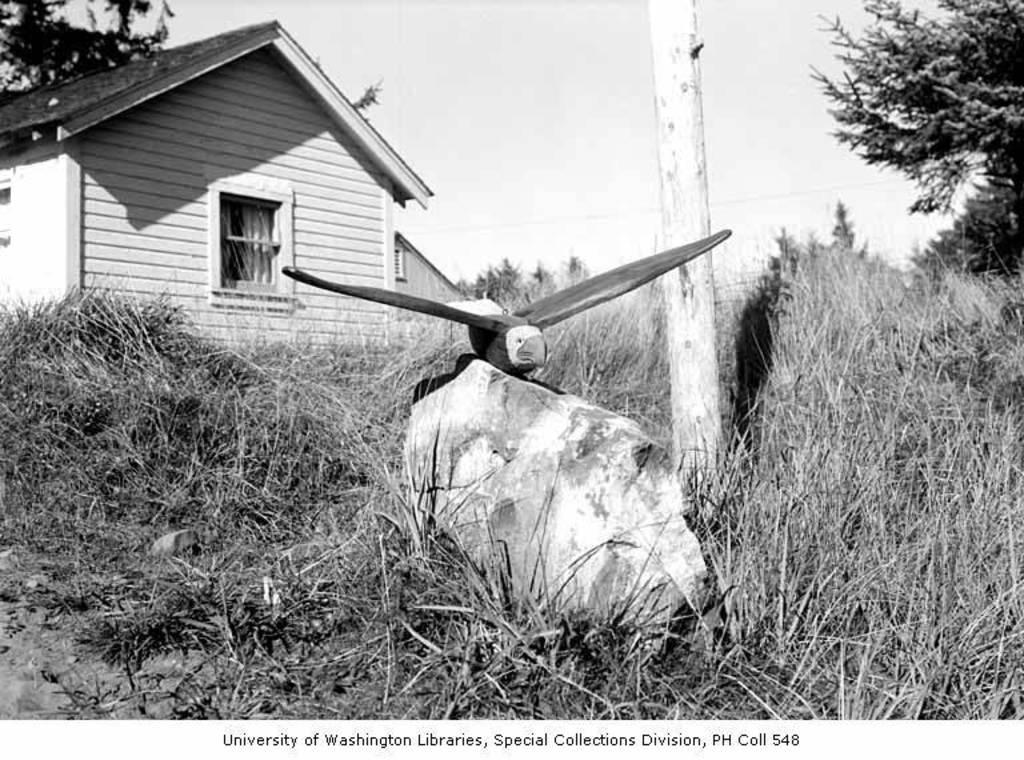How would you summarize this image in a sentence or two? This is a black and white. In this image we can see there is a house. There are plants and trees. There is an object on the rock. In the background we can see the sky. 